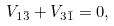Convert formula to latex. <formula><loc_0><loc_0><loc_500><loc_500>V _ { 1 \bar { 3 } } + V _ { 3 \bar { 1 } } = 0 ,</formula> 